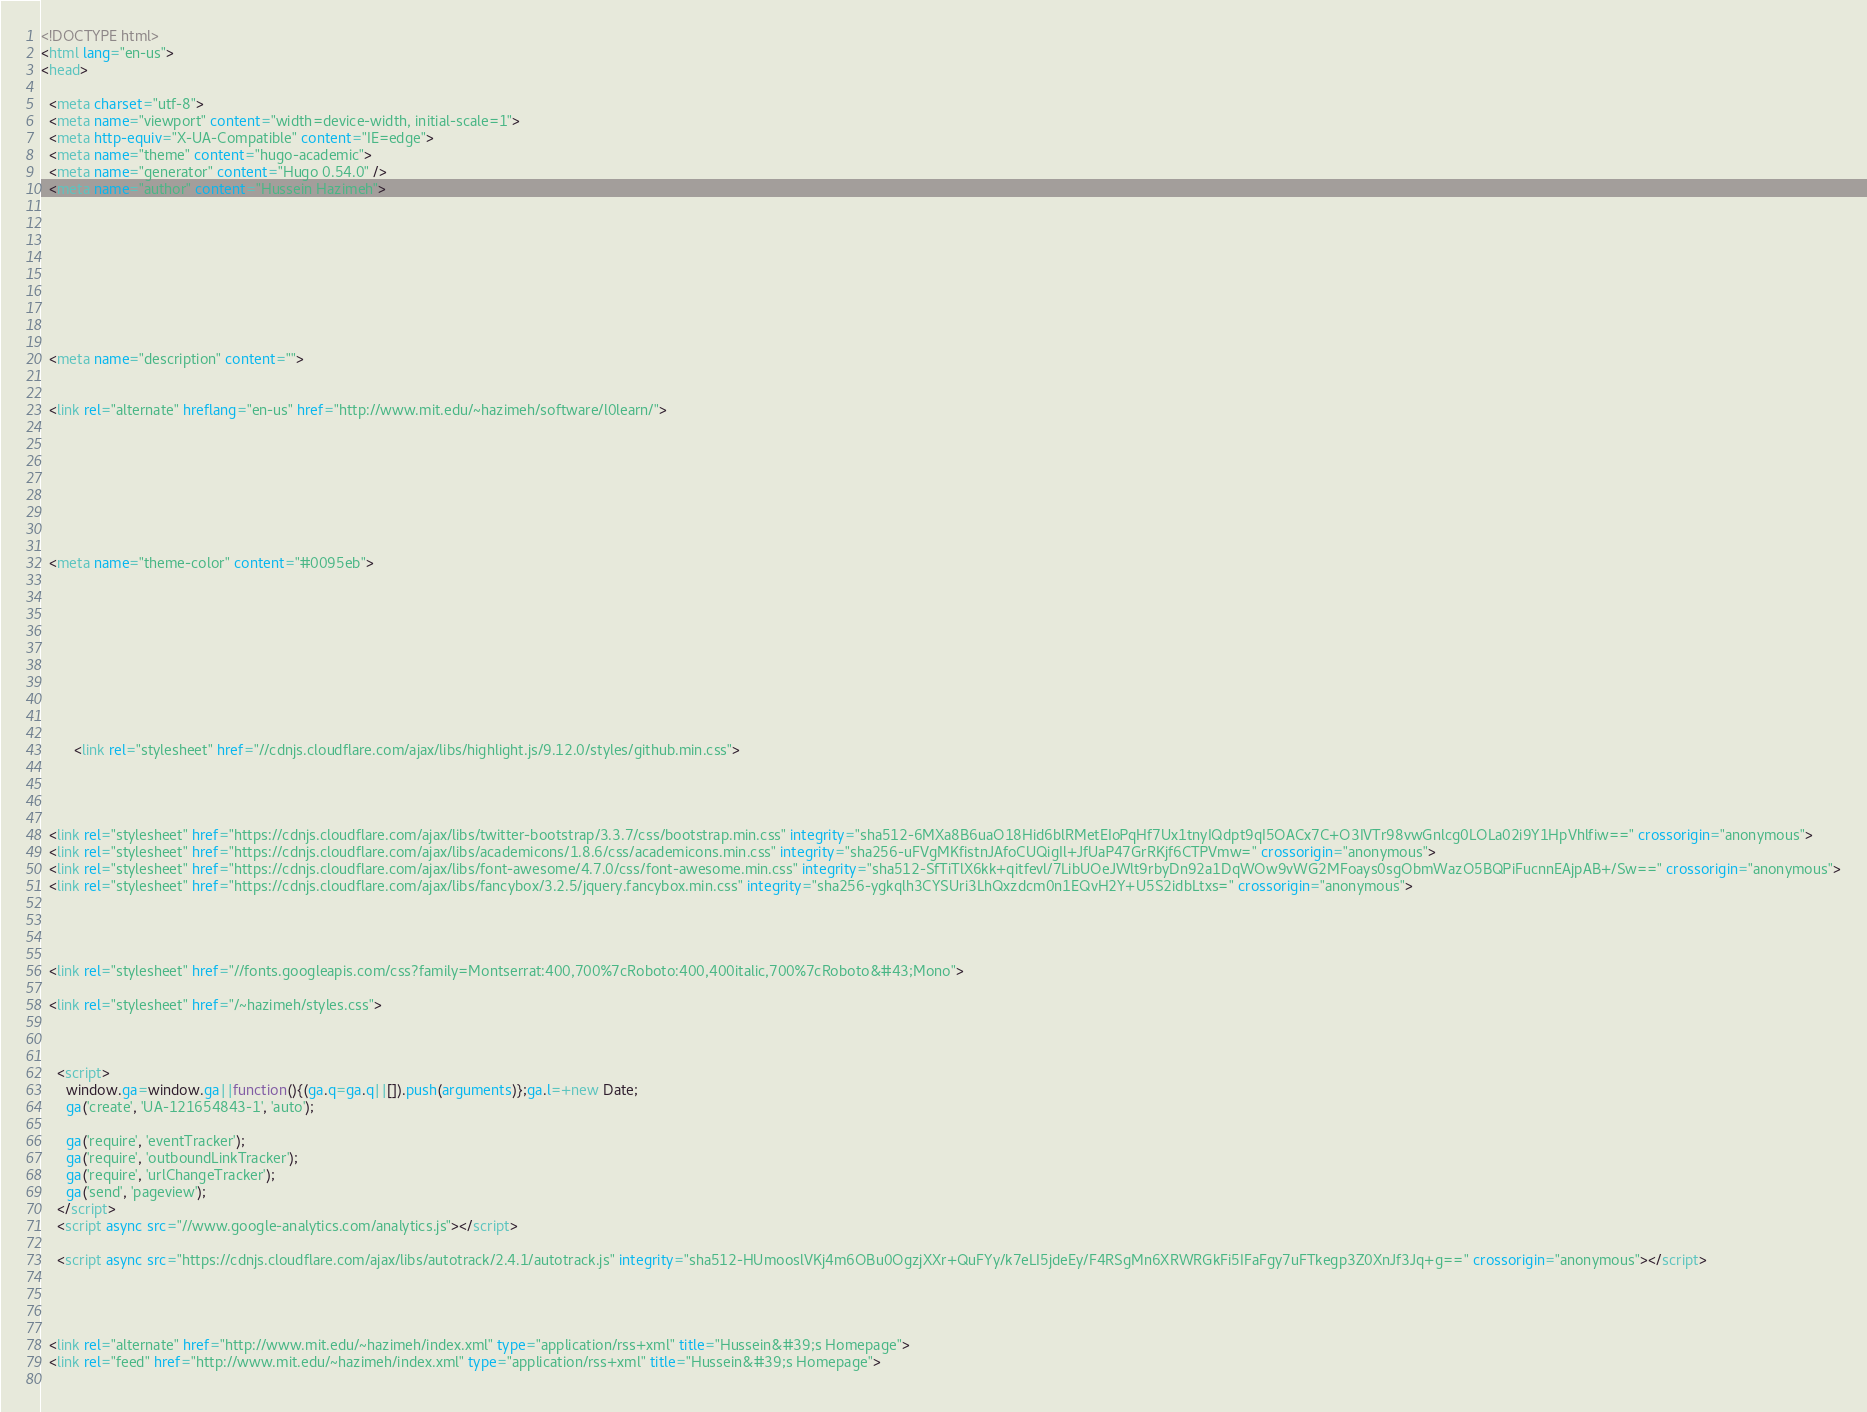<code> <loc_0><loc_0><loc_500><loc_500><_HTML_><!DOCTYPE html>
<html lang="en-us">
<head>

  <meta charset="utf-8">
  <meta name="viewport" content="width=device-width, initial-scale=1">
  <meta http-equiv="X-UA-Compatible" content="IE=edge">
  <meta name="theme" content="hugo-academic">
  <meta name="generator" content="Hugo 0.54.0" />
  <meta name="author" content="Hussein Hazimeh">

  
  
  
  
    
      
    
  
  <meta name="description" content="">

  
  <link rel="alternate" hreflang="en-us" href="http://www.mit.edu/~hazimeh/software/l0learn/">

  


  

  
  
  <meta name="theme-color" content="#0095eb">
  
  
  
  
    
  
  
    
    
      
        <link rel="stylesheet" href="//cdnjs.cloudflare.com/ajax/libs/highlight.js/9.12.0/styles/github.min.css">
      
    
  
  
  <link rel="stylesheet" href="https://cdnjs.cloudflare.com/ajax/libs/twitter-bootstrap/3.3.7/css/bootstrap.min.css" integrity="sha512-6MXa8B6uaO18Hid6blRMetEIoPqHf7Ux1tnyIQdpt9qI5OACx7C+O3IVTr98vwGnlcg0LOLa02i9Y1HpVhlfiw==" crossorigin="anonymous">
  <link rel="stylesheet" href="https://cdnjs.cloudflare.com/ajax/libs/academicons/1.8.6/css/academicons.min.css" integrity="sha256-uFVgMKfistnJAfoCUQigIl+JfUaP47GrRKjf6CTPVmw=" crossorigin="anonymous">
  <link rel="stylesheet" href="https://cdnjs.cloudflare.com/ajax/libs/font-awesome/4.7.0/css/font-awesome.min.css" integrity="sha512-SfTiTlX6kk+qitfevl/7LibUOeJWlt9rbyDn92a1DqWOw9vWG2MFoays0sgObmWazO5BQPiFucnnEAjpAB+/Sw==" crossorigin="anonymous">
  <link rel="stylesheet" href="https://cdnjs.cloudflare.com/ajax/libs/fancybox/3.2.5/jquery.fancybox.min.css" integrity="sha256-ygkqlh3CYSUri3LhQxzdcm0n1EQvH2Y+U5S2idbLtxs=" crossorigin="anonymous">
  
  
  
  
  <link rel="stylesheet" href="//fonts.googleapis.com/css?family=Montserrat:400,700%7cRoboto:400,400italic,700%7cRoboto&#43;Mono">
  
  <link rel="stylesheet" href="/~hazimeh/styles.css">
  

  
    <script>
      window.ga=window.ga||function(){(ga.q=ga.q||[]).push(arguments)};ga.l=+new Date;
      ga('create', 'UA-121654843-1', 'auto');
      
      ga('require', 'eventTracker');
      ga('require', 'outboundLinkTracker');
      ga('require', 'urlChangeTracker');
      ga('send', 'pageview');
    </script>
    <script async src="//www.google-analytics.com/analytics.js"></script>
    
    <script async src="https://cdnjs.cloudflare.com/ajax/libs/autotrack/2.4.1/autotrack.js" integrity="sha512-HUmooslVKj4m6OBu0OgzjXXr+QuFYy/k7eLI5jdeEy/F4RSgMn6XRWRGkFi5IFaFgy7uFTkegp3Z0XnJf3Jq+g==" crossorigin="anonymous"></script>
    
  

  
  <link rel="alternate" href="http://www.mit.edu/~hazimeh/index.xml" type="application/rss+xml" title="Hussein&#39;s Homepage">
  <link rel="feed" href="http://www.mit.edu/~hazimeh/index.xml" type="application/rss+xml" title="Hussein&#39;s Homepage">
  
</code> 